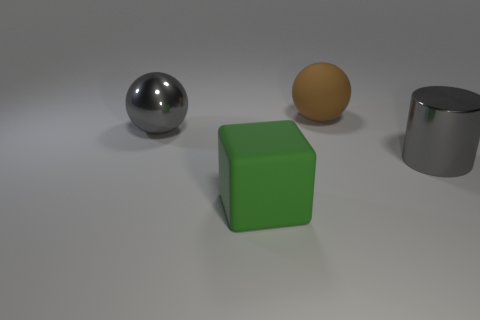Add 3 metallic things. How many objects exist? 7 Subtract all blocks. How many objects are left? 3 Subtract all purple metallic blocks. Subtract all green matte objects. How many objects are left? 3 Add 4 gray metal spheres. How many gray metal spheres are left? 5 Add 4 green blocks. How many green blocks exist? 5 Subtract 0 purple balls. How many objects are left? 4 